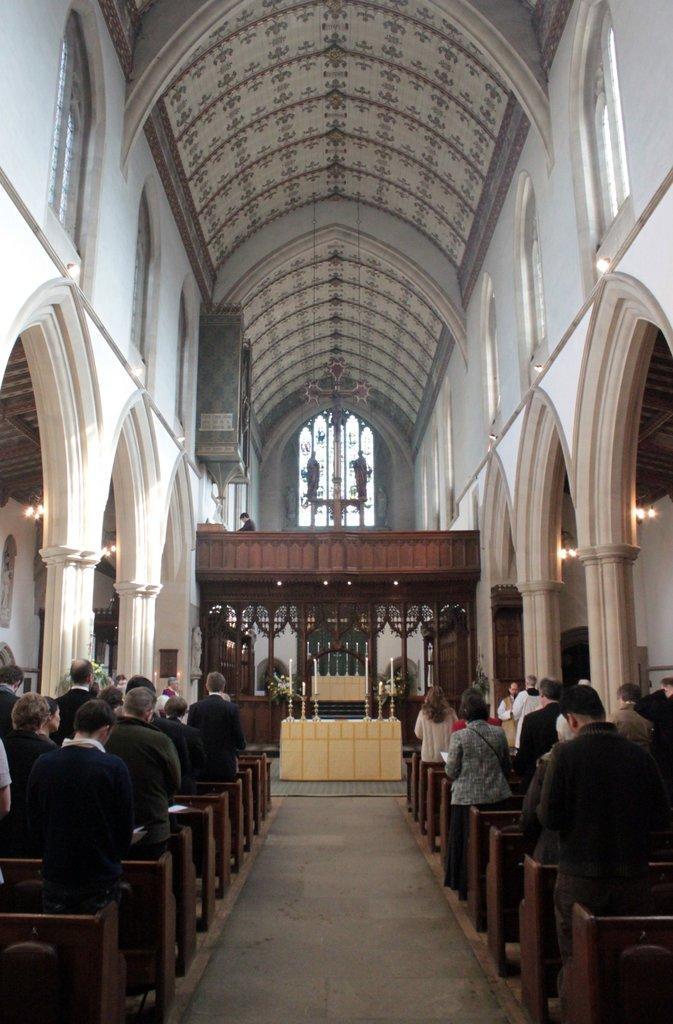Could you give a brief overview of what you see in this image? This image is taken in the church. In this image there are people standing. In the center there is an alter. We can see candles. At the top there is a roof and we can see pillars. 